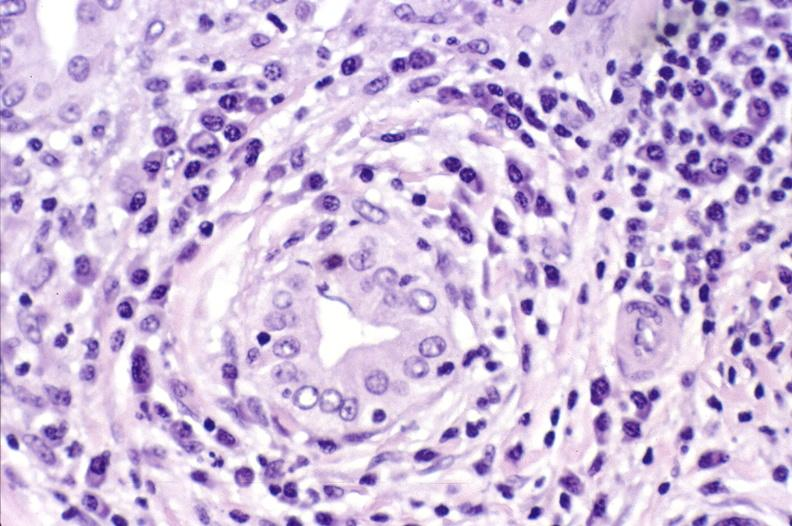what is present?
Answer the question using a single word or phrase. Liver 